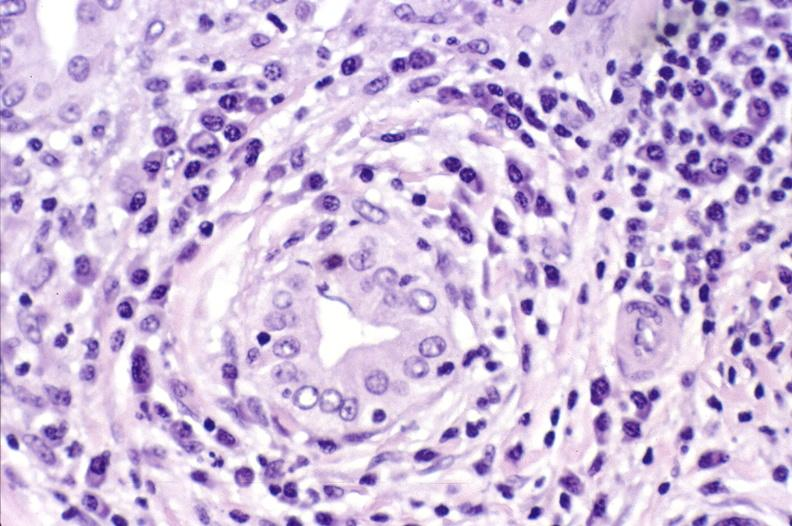what is present?
Answer the question using a single word or phrase. Liver 